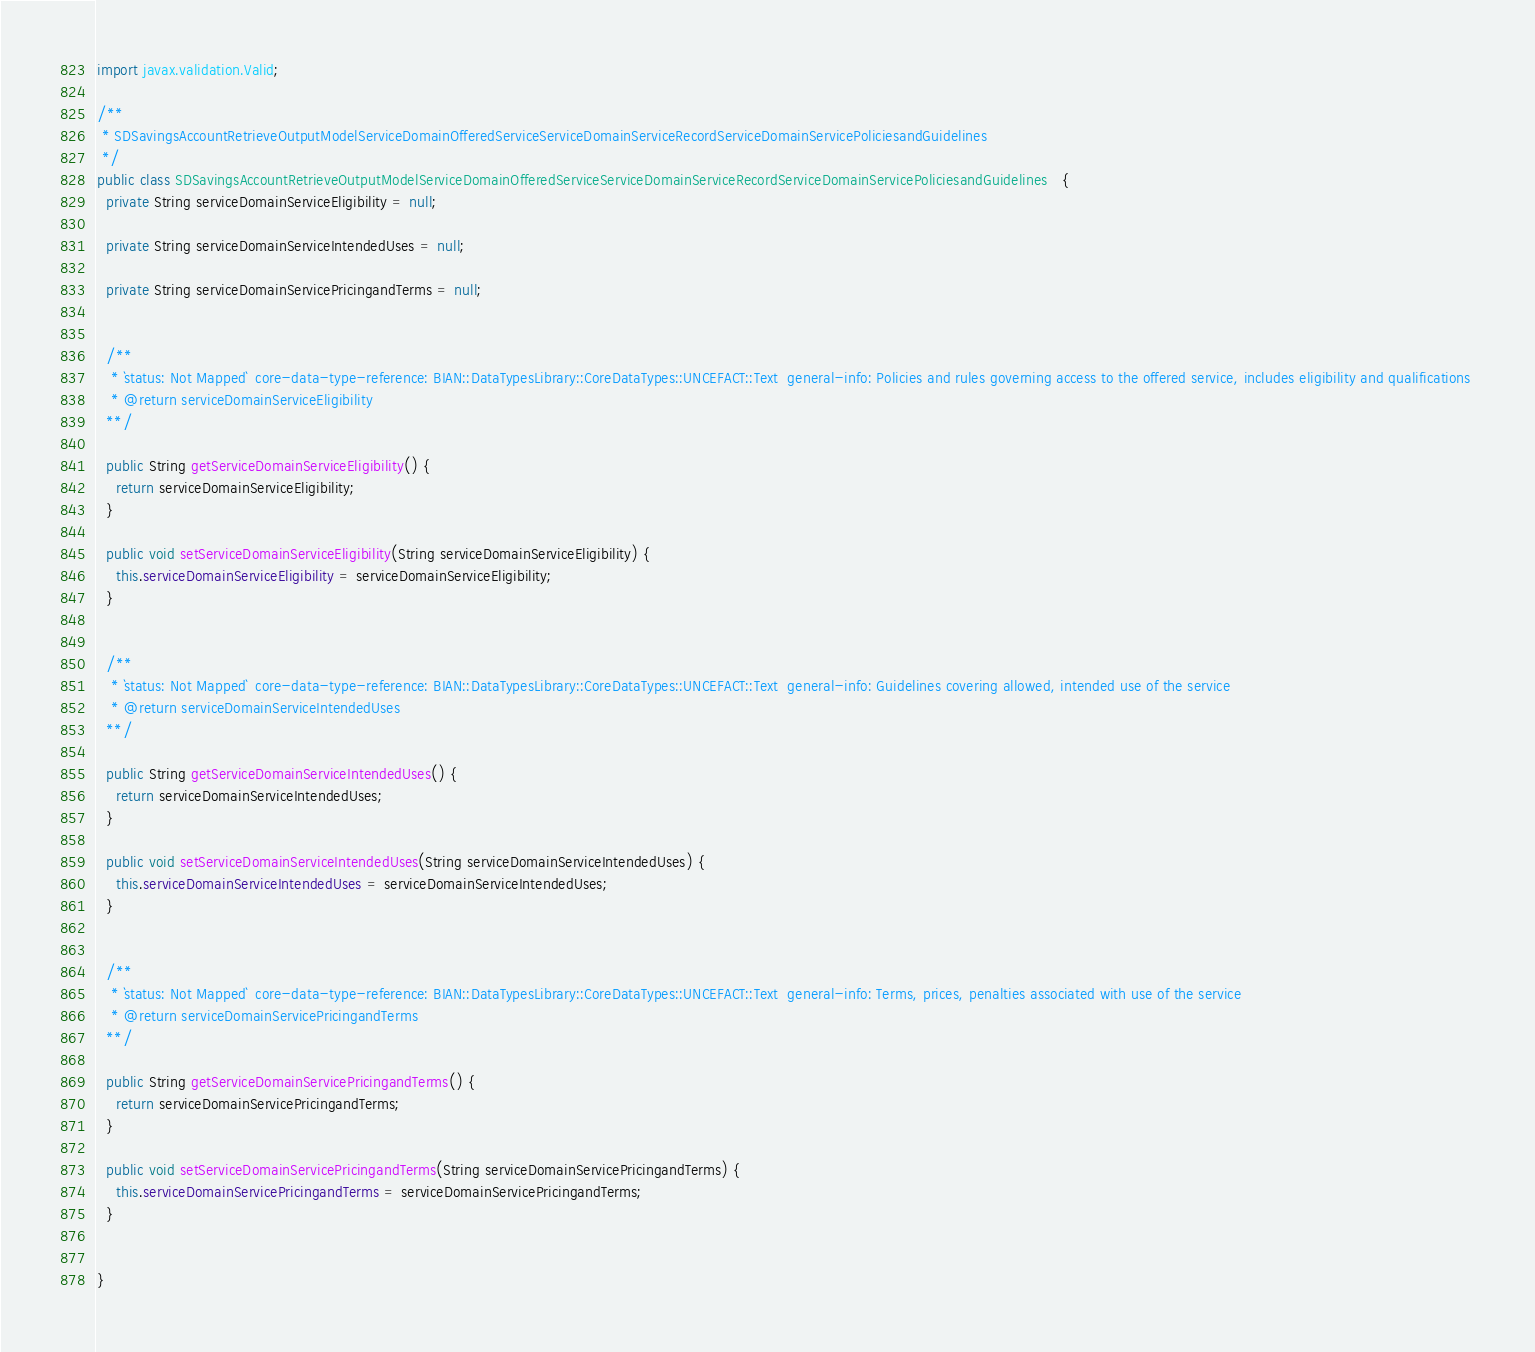Convert code to text. <code><loc_0><loc_0><loc_500><loc_500><_Java_>import javax.validation.Valid;
  
/**
 * SDSavingsAccountRetrieveOutputModelServiceDomainOfferedServiceServiceDomainServiceRecordServiceDomainServicePoliciesandGuidelines
 */
public class SDSavingsAccountRetrieveOutputModelServiceDomainOfferedServiceServiceDomainServiceRecordServiceDomainServicePoliciesandGuidelines   {
  private String serviceDomainServiceEligibility = null;

  private String serviceDomainServiceIntendedUses = null;

  private String serviceDomainServicePricingandTerms = null;


  /**
   * `status: Not Mapped`  core-data-type-reference: BIAN::DataTypesLibrary::CoreDataTypes::UNCEFACT::Text  general-info: Policies and rules governing access to the offered service, includes eligibility and qualifications 
   * @return serviceDomainServiceEligibility
  **/

  public String getServiceDomainServiceEligibility() {
    return serviceDomainServiceEligibility;
  }

  public void setServiceDomainServiceEligibility(String serviceDomainServiceEligibility) {
    this.serviceDomainServiceEligibility = serviceDomainServiceEligibility;
  }


  /**
   * `status: Not Mapped`  core-data-type-reference: BIAN::DataTypesLibrary::CoreDataTypes::UNCEFACT::Text  general-info: Guidelines covering allowed, intended use of the service 
   * @return serviceDomainServiceIntendedUses
  **/

  public String getServiceDomainServiceIntendedUses() {
    return serviceDomainServiceIntendedUses;
  }

  public void setServiceDomainServiceIntendedUses(String serviceDomainServiceIntendedUses) {
    this.serviceDomainServiceIntendedUses = serviceDomainServiceIntendedUses;
  }


  /**
   * `status: Not Mapped`  core-data-type-reference: BIAN::DataTypesLibrary::CoreDataTypes::UNCEFACT::Text  general-info: Terms, prices, penalties associated with use of the service 
   * @return serviceDomainServicePricingandTerms
  **/

  public String getServiceDomainServicePricingandTerms() {
    return serviceDomainServicePricingandTerms;
  }

  public void setServiceDomainServicePricingandTerms(String serviceDomainServicePricingandTerms) {
    this.serviceDomainServicePricingandTerms = serviceDomainServicePricingandTerms;
  }


}

</code> 